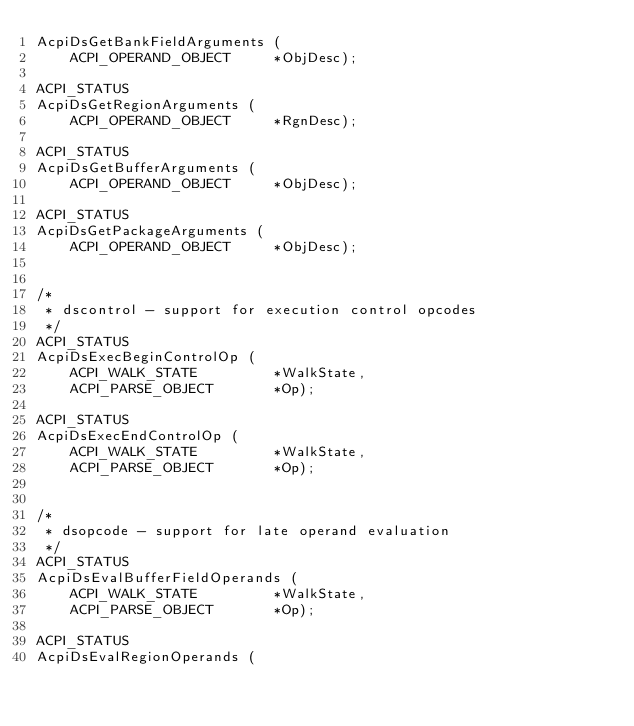Convert code to text. <code><loc_0><loc_0><loc_500><loc_500><_C_>AcpiDsGetBankFieldArguments (
    ACPI_OPERAND_OBJECT     *ObjDesc);

ACPI_STATUS
AcpiDsGetRegionArguments (
    ACPI_OPERAND_OBJECT     *RgnDesc);

ACPI_STATUS
AcpiDsGetBufferArguments (
    ACPI_OPERAND_OBJECT     *ObjDesc);

ACPI_STATUS
AcpiDsGetPackageArguments (
    ACPI_OPERAND_OBJECT     *ObjDesc);


/*
 * dscontrol - support for execution control opcodes
 */
ACPI_STATUS
AcpiDsExecBeginControlOp (
    ACPI_WALK_STATE         *WalkState,
    ACPI_PARSE_OBJECT       *Op);

ACPI_STATUS
AcpiDsExecEndControlOp (
    ACPI_WALK_STATE         *WalkState,
    ACPI_PARSE_OBJECT       *Op);


/*
 * dsopcode - support for late operand evaluation
 */
ACPI_STATUS
AcpiDsEvalBufferFieldOperands (
    ACPI_WALK_STATE         *WalkState,
    ACPI_PARSE_OBJECT       *Op);

ACPI_STATUS
AcpiDsEvalRegionOperands (</code> 